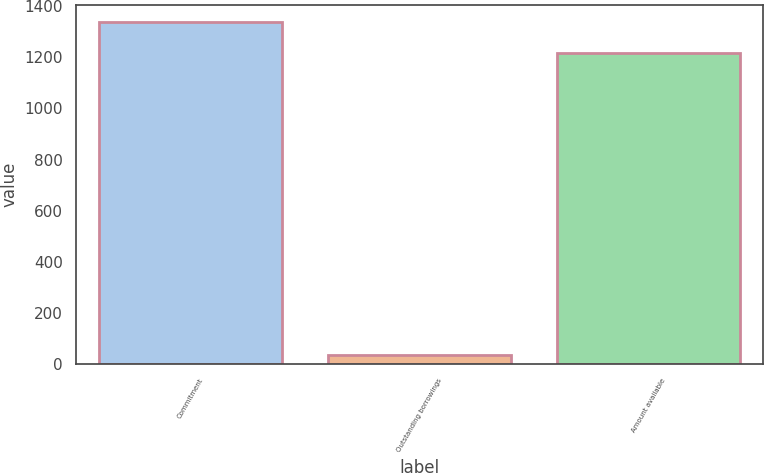Convert chart. <chart><loc_0><loc_0><loc_500><loc_500><bar_chart><fcel>Commitment<fcel>Outstanding borrowings<fcel>Amount available<nl><fcel>1337.6<fcel>34<fcel>1216<nl></chart> 